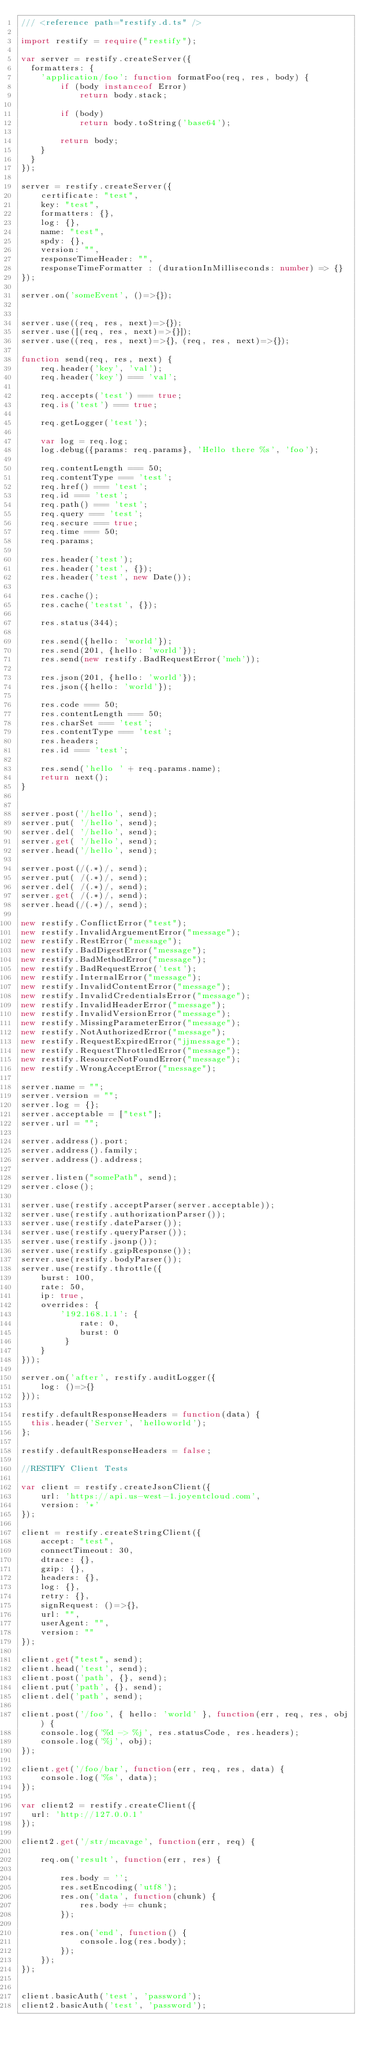<code> <loc_0><loc_0><loc_500><loc_500><_TypeScript_>/// <reference path="restify.d.ts" />

import restify = require("restify");

var server = restify.createServer({
  formatters: {
    'application/foo': function formatFoo(req, res, body) {
        if (body instanceof Error)
            return body.stack;

        if (body)
            return body.toString('base64');

        return body;
    }
  }
});

server = restify.createServer({
    certificate: "test",
    key: "test",
    formatters: {},
    log: {},
    name: "test",
    spdy: {},
    version: "",
    responseTimeHeader: "",
    responseTimeFormatter : (durationInMilliseconds: number) => {}
});

server.on('someEvent', ()=>{});


server.use((req, res, next)=>{});
server.use([(req, res, next)=>{}]);
server.use((req, res, next)=>{}, (req, res, next)=>{});

function send(req, res, next) {
    req.header('key', 'val');
    req.header('key') === 'val';
    
    req.accepts('test') === true;
    req.is('test') === true;

    req.getLogger('test');

    var log = req.log;
    log.debug({params: req.params}, 'Hello there %s', 'foo');

    req.contentLength === 50;
    req.contentType === 'test';
    req.href() === 'test';
    req.id === 'test';
    req.path() === 'test';
    req.query === 'test';
    req.secure === true;
    req.time === 50;
    req.params;

    res.header('test');
    res.header('test', {});
    res.header('test', new Date());

    res.cache();
    res.cache('testst', {});

    res.status(344);

    res.send({hello: 'world'});
    res.send(201, {hello: 'world'});
    res.send(new restify.BadRequestError('meh'));

    res.json(201, {hello: 'world'});
    res.json({hello: 'world'});

    res.code === 50;
    res.contentLength === 50;
    res.charSet === 'test';
    res.contentType === 'test';
    res.headers;
    res.id === 'test';

    res.send('hello ' + req.params.name);
    return next();
}


server.post('/hello', send);
server.put( '/hello', send);
server.del( '/hello', send);
server.get( '/hello', send);
server.head('/hello', send);

server.post(/(.*)/, send);
server.put( /(.*)/, send);
server.del( /(.*)/, send);
server.get( /(.*)/, send);
server.head(/(.*)/, send);

new restify.ConflictError("test");
new restify.InvalidArguementError("message");
new restify.RestError("message");
new restify.BadDigestError("message");
new restify.BadMethodError("message");
new restify.BadRequestError('test');
new restify.InternalError("message");
new restify.InvalidContentError("message");
new restify.InvalidCredentialsError("message");
new restify.InvalidHeaderError("message");
new restify.InvalidVersionError("message");
new restify.MissingParameterError("message");
new restify.NotAuthorizedError("message");
new restify.RequestExpiredError("jjmessage");
new restify.RequestThrottledError("message");
new restify.ResourceNotFoundError("message");
new restify.WrongAcceptError("message");

server.name = "";
server.version = "";
server.log = {};
server.acceptable = ["test"];
server.url = "";

server.address().port;
server.address().family;
server.address().address;

server.listen("somePath", send);
server.close();

server.use(restify.acceptParser(server.acceptable));
server.use(restify.authorizationParser());
server.use(restify.dateParser());
server.use(restify.queryParser());
server.use(restify.jsonp());
server.use(restify.gzipResponse());
server.use(restify.bodyParser());
server.use(restify.throttle({
    burst: 100,
    rate: 50,
    ip: true,
    overrides: {
        '192.168.1.1': {
            rate: 0,
            burst: 0
         }
    }
}));

server.on('after', restify.auditLogger({
    log: ()=>{}
}));

restify.defaultResponseHeaders = function(data) {
  this.header('Server', 'helloworld');
};

restify.defaultResponseHeaders = false;

//RESTIFY Client Tests

var client = restify.createJsonClient({
    url: 'https://api.us-west-1.joyentcloud.com',
    version: '*'
});

client = restify.createStringClient({
    accept: "test",
    connectTimeout: 30,
    dtrace: {},
    gzip: {},
    headers: {},
    log: {},
    retry: {},
    signRequest: ()=>{},
    url: "",
    userAgent: "",
    version: ""
});

client.get("test", send);
client.head('test', send);
client.post('path', {}, send);
client.put('path', {}, send);
client.del('path', send);

client.post('/foo', { hello: 'world' }, function(err, req, res, obj) {
    console.log('%d -> %j', res.statusCode, res.headers);
    console.log('%j', obj);
});

client.get('/foo/bar', function(err, req, res, data) {
    console.log('%s', data);
});

var client2 = restify.createClient({
  url: 'http://127.0.0.1'
});

client2.get('/str/mcavage', function(err, req) {

    req.on('result', function(err, res) {

        res.body = '';
        res.setEncoding('utf8');
        res.on('data', function(chunk) {
            res.body += chunk;
        });

        res.on('end', function() {
            console.log(res.body);
        });
    });
});
  

client.basicAuth('test', 'password');
client2.basicAuth('test', 'password');
</code> 